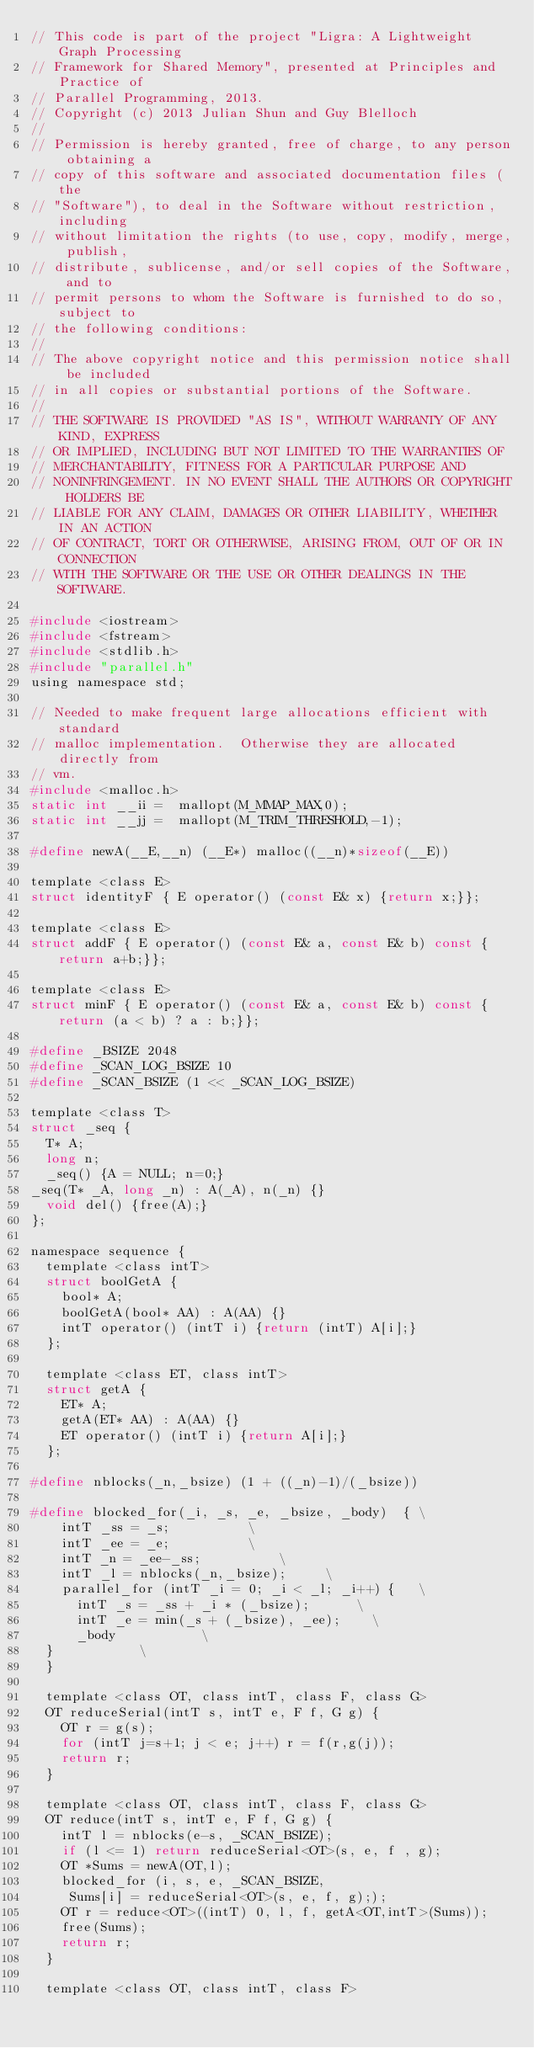Convert code to text. <code><loc_0><loc_0><loc_500><loc_500><_C_>// This code is part of the project "Ligra: A Lightweight Graph Processing
// Framework for Shared Memory", presented at Principles and Practice of 
// Parallel Programming, 2013.
// Copyright (c) 2013 Julian Shun and Guy Blelloch
//
// Permission is hereby granted, free of charge, to any person obtaining a
// copy of this software and associated documentation files (the
// "Software"), to deal in the Software without restriction, including
// without limitation the rights (to use, copy, modify, merge, publish,
// distribute, sublicense, and/or sell copies of the Software, and to
// permit persons to whom the Software is furnished to do so, subject to
// the following conditions:
//
// The above copyright notice and this permission notice shall be included
// in all copies or substantial portions of the Software.
//
// THE SOFTWARE IS PROVIDED "AS IS", WITHOUT WARRANTY OF ANY KIND, EXPRESS
// OR IMPLIED, INCLUDING BUT NOT LIMITED TO THE WARRANTIES OF
// MERCHANTABILITY, FITNESS FOR A PARTICULAR PURPOSE AND
// NONINFRINGEMENT. IN NO EVENT SHALL THE AUTHORS OR COPYRIGHT HOLDERS BE
// LIABLE FOR ANY CLAIM, DAMAGES OR OTHER LIABILITY, WHETHER IN AN ACTION
// OF CONTRACT, TORT OR OTHERWISE, ARISING FROM, OUT OF OR IN CONNECTION
// WITH THE SOFTWARE OR THE USE OR OTHER DEALINGS IN THE SOFTWARE.

#include <iostream>
#include <fstream>
#include <stdlib.h>
#include "parallel.h"
using namespace std;

// Needed to make frequent large allocations efficient with standard
// malloc implementation.  Otherwise they are allocated directly from
// vm.
#include <malloc.h>
static int __ii =  mallopt(M_MMAP_MAX,0);
static int __jj =  mallopt(M_TRIM_THRESHOLD,-1);

#define newA(__E,__n) (__E*) malloc((__n)*sizeof(__E))

template <class E>
struct identityF { E operator() (const E& x) {return x;}};

template <class E>
struct addF { E operator() (const E& a, const E& b) const {return a+b;}};

template <class E>
struct minF { E operator() (const E& a, const E& b) const {return (a < b) ? a : b;}};

#define _BSIZE 2048
#define _SCAN_LOG_BSIZE 10
#define _SCAN_BSIZE (1 << _SCAN_LOG_BSIZE)

template <class T>
struct _seq {
  T* A;
  long n;
  _seq() {A = NULL; n=0;}
_seq(T* _A, long _n) : A(_A), n(_n) {}
  void del() {free(A);}
};

namespace sequence {
  template <class intT>
  struct boolGetA {
    bool* A;
    boolGetA(bool* AA) : A(AA) {}
    intT operator() (intT i) {return (intT) A[i];}
  };

  template <class ET, class intT>
  struct getA {
    ET* A;
    getA(ET* AA) : A(AA) {}
    ET operator() (intT i) {return A[i];}
  };

#define nblocks(_n,_bsize) (1 + ((_n)-1)/(_bsize))

#define blocked_for(_i, _s, _e, _bsize, _body)  {	\
    intT _ss = _s;					\
    intT _ee = _e;					\
    intT _n = _ee-_ss;					\
    intT _l = nblocks(_n,_bsize);			\
    parallel_for (intT _i = 0; _i < _l; _i++) {		\
      intT _s = _ss + _i * (_bsize);			\
      intT _e = min(_s + (_bsize), _ee);		\
      _body						\
	}						\
  }

  template <class OT, class intT, class F, class G> 
  OT reduceSerial(intT s, intT e, F f, G g) {
    OT r = g(s);
    for (intT j=s+1; j < e; j++) r = f(r,g(j));
    return r;
  }

  template <class OT, class intT, class F, class G> 
  OT reduce(intT s, intT e, F f, G g) {
    intT l = nblocks(e-s, _SCAN_BSIZE);
    if (l <= 1) return reduceSerial<OT>(s, e, f , g);
    OT *Sums = newA(OT,l);
    blocked_for (i, s, e, _SCAN_BSIZE, 
		 Sums[i] = reduceSerial<OT>(s, e, f, g););
    OT r = reduce<OT>((intT) 0, l, f, getA<OT,intT>(Sums));
    free(Sums);
    return r;
  }

  template <class OT, class intT, class F> </code> 